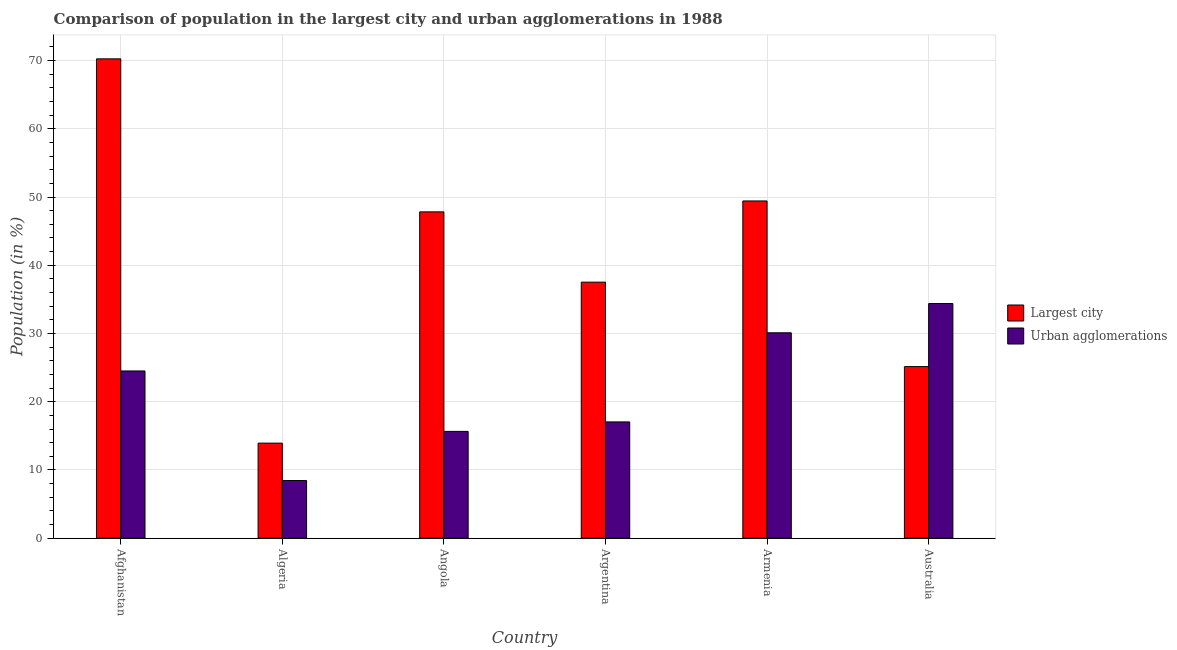Are the number of bars on each tick of the X-axis equal?
Provide a short and direct response. Yes. What is the label of the 2nd group of bars from the left?
Give a very brief answer. Algeria. What is the population in urban agglomerations in Australia?
Your response must be concise. 34.39. Across all countries, what is the maximum population in urban agglomerations?
Keep it short and to the point. 34.39. Across all countries, what is the minimum population in urban agglomerations?
Provide a short and direct response. 8.46. In which country was the population in urban agglomerations maximum?
Keep it short and to the point. Australia. In which country was the population in urban agglomerations minimum?
Your answer should be very brief. Algeria. What is the total population in the largest city in the graph?
Offer a very short reply. 244.1. What is the difference between the population in the largest city in Afghanistan and that in Angola?
Make the answer very short. 22.42. What is the difference between the population in the largest city in Angola and the population in urban agglomerations in Argentina?
Offer a very short reply. 30.78. What is the average population in the largest city per country?
Offer a terse response. 40.68. What is the difference between the population in urban agglomerations and population in the largest city in Australia?
Your answer should be compact. 9.24. In how many countries, is the population in the largest city greater than 50 %?
Provide a short and direct response. 1. What is the ratio of the population in urban agglomerations in Argentina to that in Australia?
Offer a terse response. 0.5. Is the population in the largest city in Afghanistan less than that in Australia?
Your answer should be compact. No. What is the difference between the highest and the second highest population in the largest city?
Provide a succinct answer. 20.82. What is the difference between the highest and the lowest population in urban agglomerations?
Give a very brief answer. 25.93. What does the 2nd bar from the left in Angola represents?
Provide a succinct answer. Urban agglomerations. What does the 2nd bar from the right in Australia represents?
Provide a short and direct response. Largest city. Are the values on the major ticks of Y-axis written in scientific E-notation?
Make the answer very short. No. How are the legend labels stacked?
Your response must be concise. Vertical. What is the title of the graph?
Ensure brevity in your answer.  Comparison of population in the largest city and urban agglomerations in 1988. What is the label or title of the X-axis?
Offer a terse response. Country. What is the label or title of the Y-axis?
Keep it short and to the point. Population (in %). What is the Population (in %) of Largest city in Afghanistan?
Keep it short and to the point. 70.25. What is the Population (in %) in Urban agglomerations in Afghanistan?
Keep it short and to the point. 24.51. What is the Population (in %) of Largest city in Algeria?
Your answer should be compact. 13.94. What is the Population (in %) in Urban agglomerations in Algeria?
Your response must be concise. 8.46. What is the Population (in %) in Largest city in Angola?
Ensure brevity in your answer.  47.82. What is the Population (in %) in Urban agglomerations in Angola?
Your response must be concise. 15.66. What is the Population (in %) in Largest city in Argentina?
Ensure brevity in your answer.  37.52. What is the Population (in %) in Urban agglomerations in Argentina?
Keep it short and to the point. 17.05. What is the Population (in %) in Largest city in Armenia?
Ensure brevity in your answer.  49.42. What is the Population (in %) in Urban agglomerations in Armenia?
Offer a very short reply. 30.11. What is the Population (in %) in Largest city in Australia?
Ensure brevity in your answer.  25.15. What is the Population (in %) in Urban agglomerations in Australia?
Provide a short and direct response. 34.39. Across all countries, what is the maximum Population (in %) of Largest city?
Offer a terse response. 70.25. Across all countries, what is the maximum Population (in %) of Urban agglomerations?
Provide a succinct answer. 34.39. Across all countries, what is the minimum Population (in %) in Largest city?
Offer a terse response. 13.94. Across all countries, what is the minimum Population (in %) of Urban agglomerations?
Provide a short and direct response. 8.46. What is the total Population (in %) in Largest city in the graph?
Provide a succinct answer. 244.1. What is the total Population (in %) in Urban agglomerations in the graph?
Give a very brief answer. 130.16. What is the difference between the Population (in %) in Largest city in Afghanistan and that in Algeria?
Give a very brief answer. 56.31. What is the difference between the Population (in %) of Urban agglomerations in Afghanistan and that in Algeria?
Your response must be concise. 16.06. What is the difference between the Population (in %) in Largest city in Afghanistan and that in Angola?
Offer a very short reply. 22.42. What is the difference between the Population (in %) in Urban agglomerations in Afghanistan and that in Angola?
Provide a short and direct response. 8.86. What is the difference between the Population (in %) of Largest city in Afghanistan and that in Argentina?
Keep it short and to the point. 32.72. What is the difference between the Population (in %) in Urban agglomerations in Afghanistan and that in Argentina?
Your response must be concise. 7.47. What is the difference between the Population (in %) in Largest city in Afghanistan and that in Armenia?
Give a very brief answer. 20.82. What is the difference between the Population (in %) in Urban agglomerations in Afghanistan and that in Armenia?
Offer a very short reply. -5.59. What is the difference between the Population (in %) in Largest city in Afghanistan and that in Australia?
Give a very brief answer. 45.09. What is the difference between the Population (in %) in Urban agglomerations in Afghanistan and that in Australia?
Offer a very short reply. -9.88. What is the difference between the Population (in %) of Largest city in Algeria and that in Angola?
Your answer should be very brief. -33.89. What is the difference between the Population (in %) of Urban agglomerations in Algeria and that in Angola?
Your answer should be very brief. -7.2. What is the difference between the Population (in %) in Largest city in Algeria and that in Argentina?
Provide a succinct answer. -23.59. What is the difference between the Population (in %) in Urban agglomerations in Algeria and that in Argentina?
Your answer should be compact. -8.59. What is the difference between the Population (in %) of Largest city in Algeria and that in Armenia?
Keep it short and to the point. -35.48. What is the difference between the Population (in %) in Urban agglomerations in Algeria and that in Armenia?
Give a very brief answer. -21.65. What is the difference between the Population (in %) in Largest city in Algeria and that in Australia?
Your response must be concise. -11.21. What is the difference between the Population (in %) in Urban agglomerations in Algeria and that in Australia?
Your response must be concise. -25.93. What is the difference between the Population (in %) of Largest city in Angola and that in Argentina?
Your response must be concise. 10.3. What is the difference between the Population (in %) in Urban agglomerations in Angola and that in Argentina?
Offer a terse response. -1.39. What is the difference between the Population (in %) of Largest city in Angola and that in Armenia?
Offer a terse response. -1.6. What is the difference between the Population (in %) in Urban agglomerations in Angola and that in Armenia?
Provide a succinct answer. -14.45. What is the difference between the Population (in %) of Largest city in Angola and that in Australia?
Provide a succinct answer. 22.67. What is the difference between the Population (in %) in Urban agglomerations in Angola and that in Australia?
Offer a very short reply. -18.74. What is the difference between the Population (in %) in Largest city in Argentina and that in Armenia?
Your answer should be very brief. -11.9. What is the difference between the Population (in %) of Urban agglomerations in Argentina and that in Armenia?
Offer a very short reply. -13.06. What is the difference between the Population (in %) in Largest city in Argentina and that in Australia?
Your answer should be very brief. 12.37. What is the difference between the Population (in %) of Urban agglomerations in Argentina and that in Australia?
Give a very brief answer. -17.35. What is the difference between the Population (in %) of Largest city in Armenia and that in Australia?
Your answer should be compact. 24.27. What is the difference between the Population (in %) in Urban agglomerations in Armenia and that in Australia?
Offer a very short reply. -4.29. What is the difference between the Population (in %) of Largest city in Afghanistan and the Population (in %) of Urban agglomerations in Algeria?
Your answer should be compact. 61.79. What is the difference between the Population (in %) of Largest city in Afghanistan and the Population (in %) of Urban agglomerations in Angola?
Offer a very short reply. 54.59. What is the difference between the Population (in %) of Largest city in Afghanistan and the Population (in %) of Urban agglomerations in Argentina?
Ensure brevity in your answer.  53.2. What is the difference between the Population (in %) of Largest city in Afghanistan and the Population (in %) of Urban agglomerations in Armenia?
Your answer should be very brief. 40.14. What is the difference between the Population (in %) in Largest city in Afghanistan and the Population (in %) in Urban agglomerations in Australia?
Make the answer very short. 35.86. What is the difference between the Population (in %) of Largest city in Algeria and the Population (in %) of Urban agglomerations in Angola?
Provide a short and direct response. -1.72. What is the difference between the Population (in %) in Largest city in Algeria and the Population (in %) in Urban agglomerations in Argentina?
Ensure brevity in your answer.  -3.11. What is the difference between the Population (in %) of Largest city in Algeria and the Population (in %) of Urban agglomerations in Armenia?
Provide a succinct answer. -16.17. What is the difference between the Population (in %) in Largest city in Algeria and the Population (in %) in Urban agglomerations in Australia?
Ensure brevity in your answer.  -20.45. What is the difference between the Population (in %) in Largest city in Angola and the Population (in %) in Urban agglomerations in Argentina?
Provide a short and direct response. 30.78. What is the difference between the Population (in %) in Largest city in Angola and the Population (in %) in Urban agglomerations in Armenia?
Provide a succinct answer. 17.72. What is the difference between the Population (in %) of Largest city in Angola and the Population (in %) of Urban agglomerations in Australia?
Give a very brief answer. 13.43. What is the difference between the Population (in %) of Largest city in Argentina and the Population (in %) of Urban agglomerations in Armenia?
Your answer should be very brief. 7.42. What is the difference between the Population (in %) in Largest city in Argentina and the Population (in %) in Urban agglomerations in Australia?
Give a very brief answer. 3.13. What is the difference between the Population (in %) in Largest city in Armenia and the Population (in %) in Urban agglomerations in Australia?
Give a very brief answer. 15.03. What is the average Population (in %) in Largest city per country?
Provide a succinct answer. 40.68. What is the average Population (in %) in Urban agglomerations per country?
Provide a succinct answer. 21.69. What is the difference between the Population (in %) of Largest city and Population (in %) of Urban agglomerations in Afghanistan?
Provide a short and direct response. 45.73. What is the difference between the Population (in %) in Largest city and Population (in %) in Urban agglomerations in Algeria?
Your answer should be very brief. 5.48. What is the difference between the Population (in %) of Largest city and Population (in %) of Urban agglomerations in Angola?
Offer a terse response. 32.17. What is the difference between the Population (in %) in Largest city and Population (in %) in Urban agglomerations in Argentina?
Offer a terse response. 20.48. What is the difference between the Population (in %) of Largest city and Population (in %) of Urban agglomerations in Armenia?
Your answer should be compact. 19.32. What is the difference between the Population (in %) in Largest city and Population (in %) in Urban agglomerations in Australia?
Offer a terse response. -9.24. What is the ratio of the Population (in %) of Largest city in Afghanistan to that in Algeria?
Your answer should be compact. 5.04. What is the ratio of the Population (in %) of Urban agglomerations in Afghanistan to that in Algeria?
Ensure brevity in your answer.  2.9. What is the ratio of the Population (in %) of Largest city in Afghanistan to that in Angola?
Make the answer very short. 1.47. What is the ratio of the Population (in %) of Urban agglomerations in Afghanistan to that in Angola?
Your response must be concise. 1.57. What is the ratio of the Population (in %) in Largest city in Afghanistan to that in Argentina?
Offer a terse response. 1.87. What is the ratio of the Population (in %) in Urban agglomerations in Afghanistan to that in Argentina?
Provide a short and direct response. 1.44. What is the ratio of the Population (in %) in Largest city in Afghanistan to that in Armenia?
Your response must be concise. 1.42. What is the ratio of the Population (in %) in Urban agglomerations in Afghanistan to that in Armenia?
Ensure brevity in your answer.  0.81. What is the ratio of the Population (in %) of Largest city in Afghanistan to that in Australia?
Give a very brief answer. 2.79. What is the ratio of the Population (in %) of Urban agglomerations in Afghanistan to that in Australia?
Provide a short and direct response. 0.71. What is the ratio of the Population (in %) in Largest city in Algeria to that in Angola?
Offer a terse response. 0.29. What is the ratio of the Population (in %) of Urban agglomerations in Algeria to that in Angola?
Keep it short and to the point. 0.54. What is the ratio of the Population (in %) in Largest city in Algeria to that in Argentina?
Keep it short and to the point. 0.37. What is the ratio of the Population (in %) of Urban agglomerations in Algeria to that in Argentina?
Your response must be concise. 0.5. What is the ratio of the Population (in %) in Largest city in Algeria to that in Armenia?
Your response must be concise. 0.28. What is the ratio of the Population (in %) of Urban agglomerations in Algeria to that in Armenia?
Ensure brevity in your answer.  0.28. What is the ratio of the Population (in %) in Largest city in Algeria to that in Australia?
Provide a short and direct response. 0.55. What is the ratio of the Population (in %) in Urban agglomerations in Algeria to that in Australia?
Offer a very short reply. 0.25. What is the ratio of the Population (in %) of Largest city in Angola to that in Argentina?
Your response must be concise. 1.27. What is the ratio of the Population (in %) of Urban agglomerations in Angola to that in Argentina?
Keep it short and to the point. 0.92. What is the ratio of the Population (in %) of Urban agglomerations in Angola to that in Armenia?
Give a very brief answer. 0.52. What is the ratio of the Population (in %) of Largest city in Angola to that in Australia?
Give a very brief answer. 1.9. What is the ratio of the Population (in %) of Urban agglomerations in Angola to that in Australia?
Offer a terse response. 0.46. What is the ratio of the Population (in %) of Largest city in Argentina to that in Armenia?
Your answer should be compact. 0.76. What is the ratio of the Population (in %) in Urban agglomerations in Argentina to that in Armenia?
Ensure brevity in your answer.  0.57. What is the ratio of the Population (in %) of Largest city in Argentina to that in Australia?
Provide a short and direct response. 1.49. What is the ratio of the Population (in %) of Urban agglomerations in Argentina to that in Australia?
Ensure brevity in your answer.  0.5. What is the ratio of the Population (in %) of Largest city in Armenia to that in Australia?
Keep it short and to the point. 1.97. What is the ratio of the Population (in %) in Urban agglomerations in Armenia to that in Australia?
Give a very brief answer. 0.88. What is the difference between the highest and the second highest Population (in %) in Largest city?
Offer a very short reply. 20.82. What is the difference between the highest and the second highest Population (in %) in Urban agglomerations?
Keep it short and to the point. 4.29. What is the difference between the highest and the lowest Population (in %) of Largest city?
Offer a terse response. 56.31. What is the difference between the highest and the lowest Population (in %) in Urban agglomerations?
Ensure brevity in your answer.  25.93. 